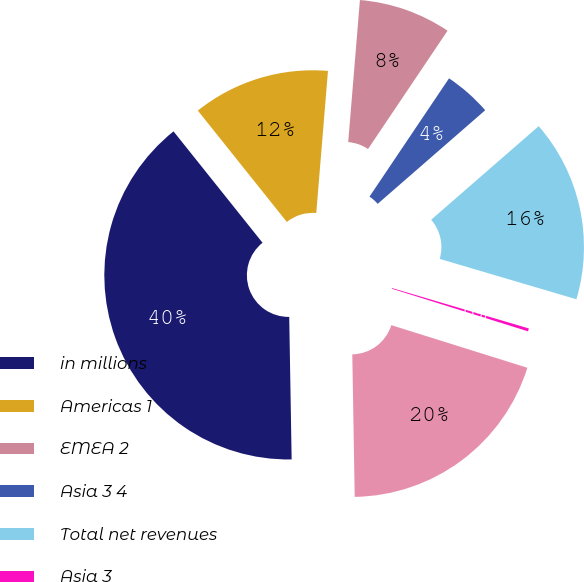Convert chart to OTSL. <chart><loc_0><loc_0><loc_500><loc_500><pie_chart><fcel>in millions<fcel>Americas 1<fcel>EMEA 2<fcel>Asia 3 4<fcel>Total net revenues<fcel>Asia 3<fcel>Subtotal<nl><fcel>39.54%<fcel>12.04%<fcel>8.11%<fcel>4.18%<fcel>15.97%<fcel>0.26%<fcel>19.9%<nl></chart> 